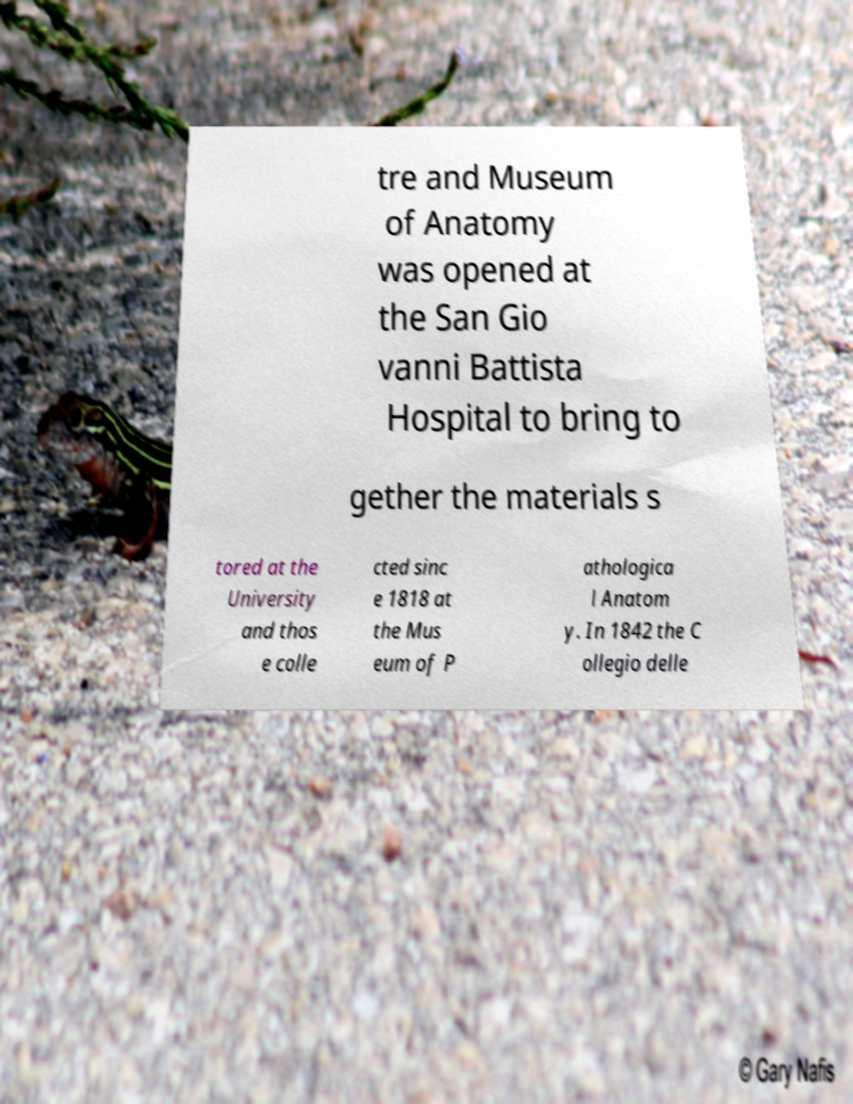For documentation purposes, I need the text within this image transcribed. Could you provide that? tre and Museum of Anatomy was opened at the San Gio vanni Battista Hospital to bring to gether the materials s tored at the University and thos e colle cted sinc e 1818 at the Mus eum of P athologica l Anatom y. In 1842 the C ollegio delle 